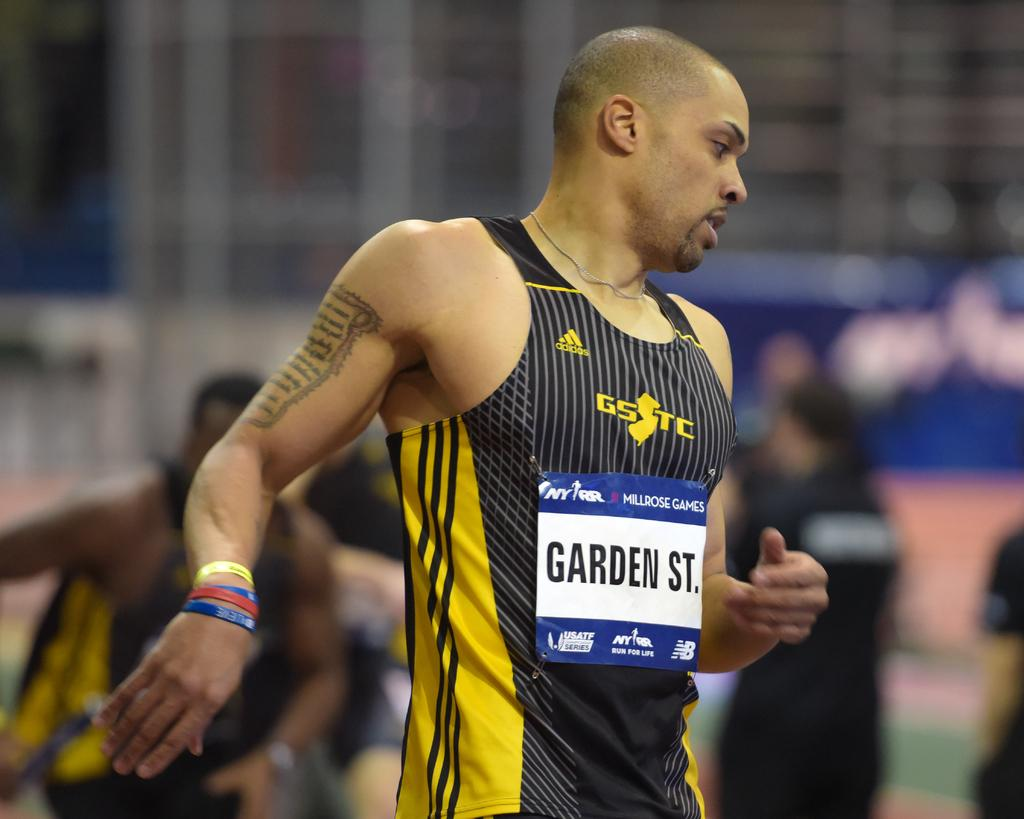<image>
Share a concise interpretation of the image provided. A runner wearing an Adidas tank top from Garden State. 